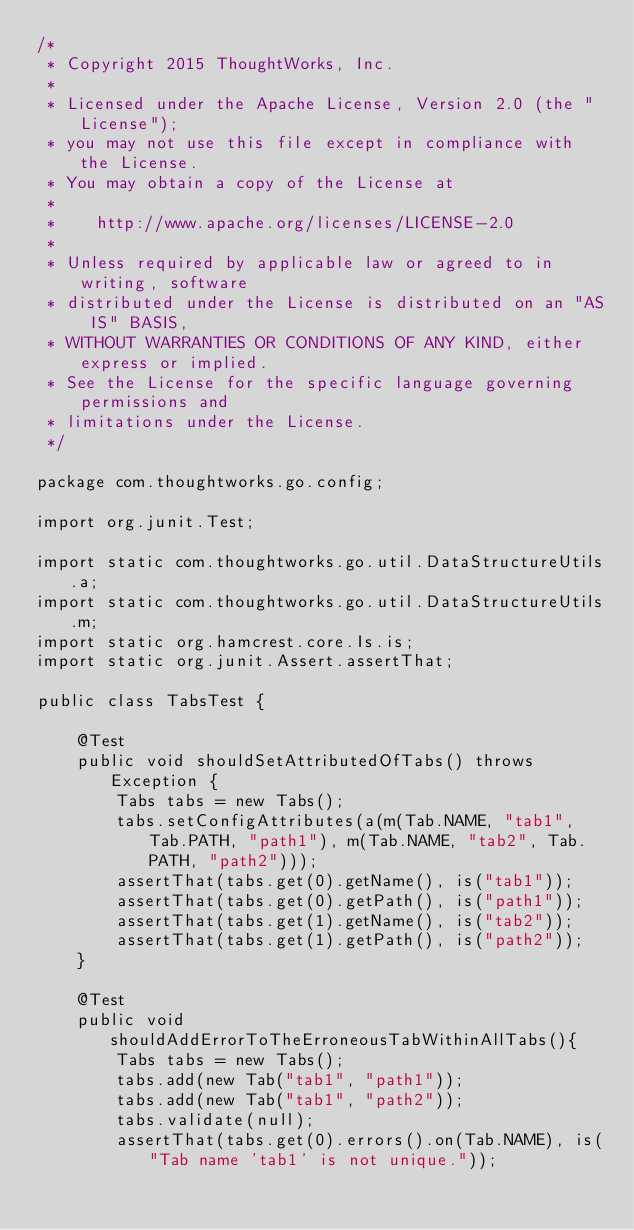<code> <loc_0><loc_0><loc_500><loc_500><_Java_>/*
 * Copyright 2015 ThoughtWorks, Inc.
 *
 * Licensed under the Apache License, Version 2.0 (the "License");
 * you may not use this file except in compliance with the License.
 * You may obtain a copy of the License at
 *
 *    http://www.apache.org/licenses/LICENSE-2.0
 *
 * Unless required by applicable law or agreed to in writing, software
 * distributed under the License is distributed on an "AS IS" BASIS,
 * WITHOUT WARRANTIES OR CONDITIONS OF ANY KIND, either express or implied.
 * See the License for the specific language governing permissions and
 * limitations under the License.
 */

package com.thoughtworks.go.config;

import org.junit.Test;

import static com.thoughtworks.go.util.DataStructureUtils.a;
import static com.thoughtworks.go.util.DataStructureUtils.m;
import static org.hamcrest.core.Is.is;
import static org.junit.Assert.assertThat;

public class TabsTest {

    @Test
    public void shouldSetAttributedOfTabs() throws Exception {
        Tabs tabs = new Tabs();
        tabs.setConfigAttributes(a(m(Tab.NAME, "tab1", Tab.PATH, "path1"), m(Tab.NAME, "tab2", Tab.PATH, "path2")));
        assertThat(tabs.get(0).getName(), is("tab1"));
        assertThat(tabs.get(0).getPath(), is("path1"));
        assertThat(tabs.get(1).getName(), is("tab2"));
        assertThat(tabs.get(1).getPath(), is("path2"));
    }

    @Test
    public void shouldAddErrorToTheErroneousTabWithinAllTabs(){
        Tabs tabs = new Tabs();
        tabs.add(new Tab("tab1", "path1"));
        tabs.add(new Tab("tab1", "path2"));
        tabs.validate(null);
        assertThat(tabs.get(0).errors().on(Tab.NAME), is("Tab name 'tab1' is not unique."));</code> 